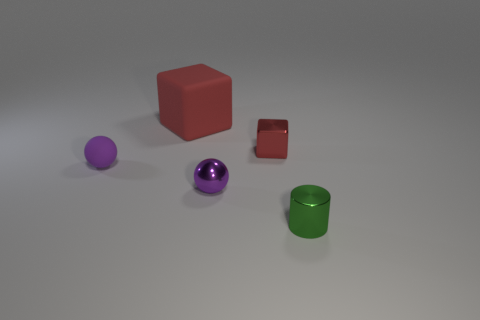Add 3 metal things. How many objects exist? 8 Subtract all cylinders. How many objects are left? 4 Add 4 large matte things. How many large matte things are left? 5 Add 1 small purple rubber spheres. How many small purple rubber spheres exist? 2 Subtract 0 yellow blocks. How many objects are left? 5 Subtract all big purple cylinders. Subtract all tiny cylinders. How many objects are left? 4 